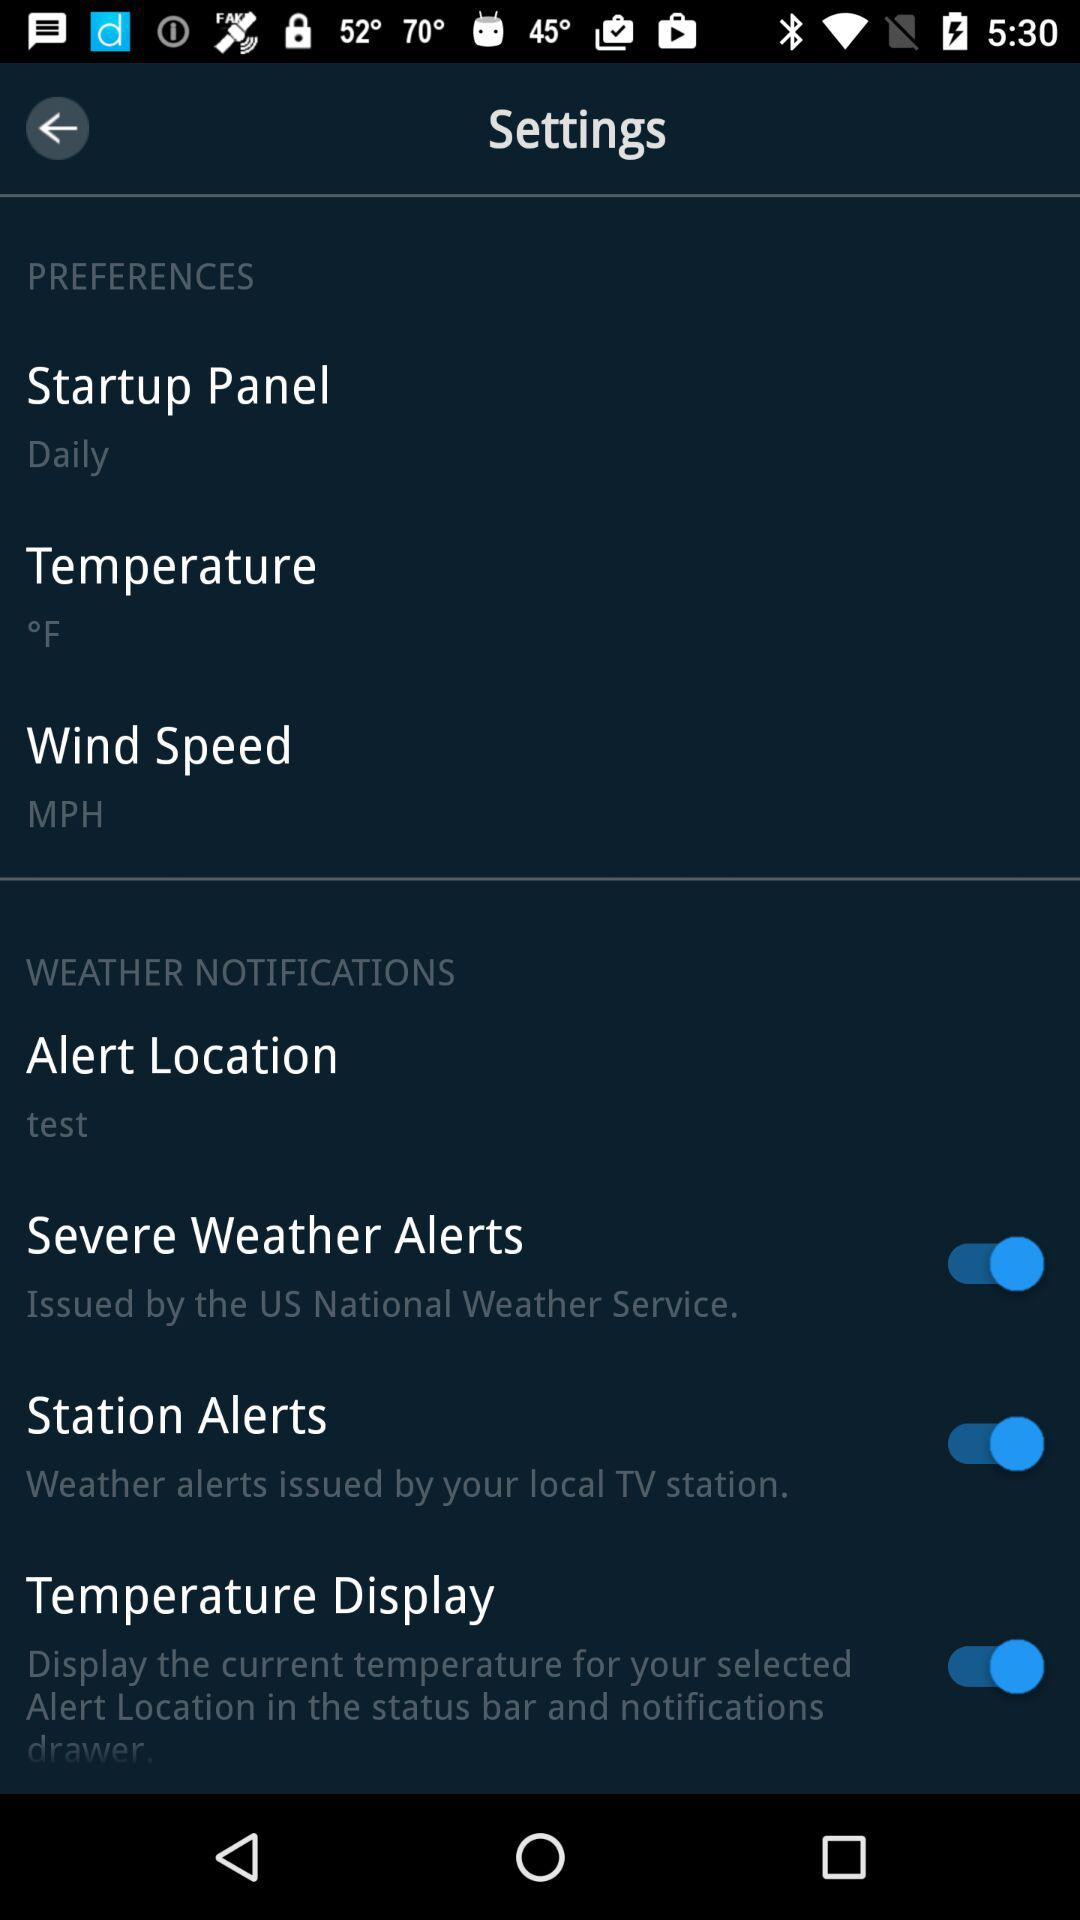What is the setting for the "Startup Panel"? The setting is "Daily". 